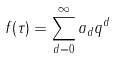Convert formula to latex. <formula><loc_0><loc_0><loc_500><loc_500>f ( \tau ) = \sum _ { d = 0 } ^ { \infty } a _ { d } q ^ { d }</formula> 